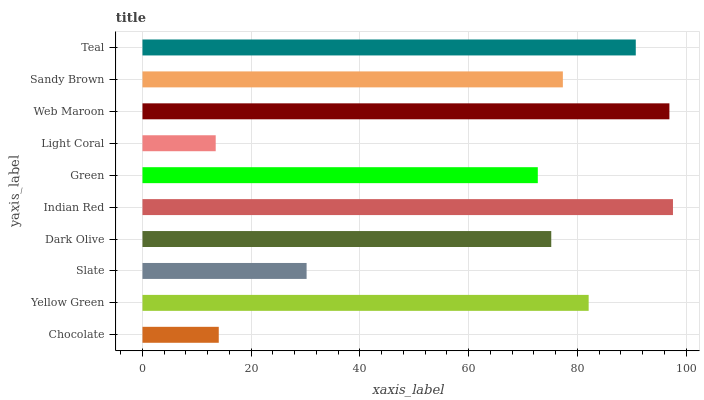Is Light Coral the minimum?
Answer yes or no. Yes. Is Indian Red the maximum?
Answer yes or no. Yes. Is Yellow Green the minimum?
Answer yes or no. No. Is Yellow Green the maximum?
Answer yes or no. No. Is Yellow Green greater than Chocolate?
Answer yes or no. Yes. Is Chocolate less than Yellow Green?
Answer yes or no. Yes. Is Chocolate greater than Yellow Green?
Answer yes or no. No. Is Yellow Green less than Chocolate?
Answer yes or no. No. Is Sandy Brown the high median?
Answer yes or no. Yes. Is Dark Olive the low median?
Answer yes or no. Yes. Is Green the high median?
Answer yes or no. No. Is Web Maroon the low median?
Answer yes or no. No. 